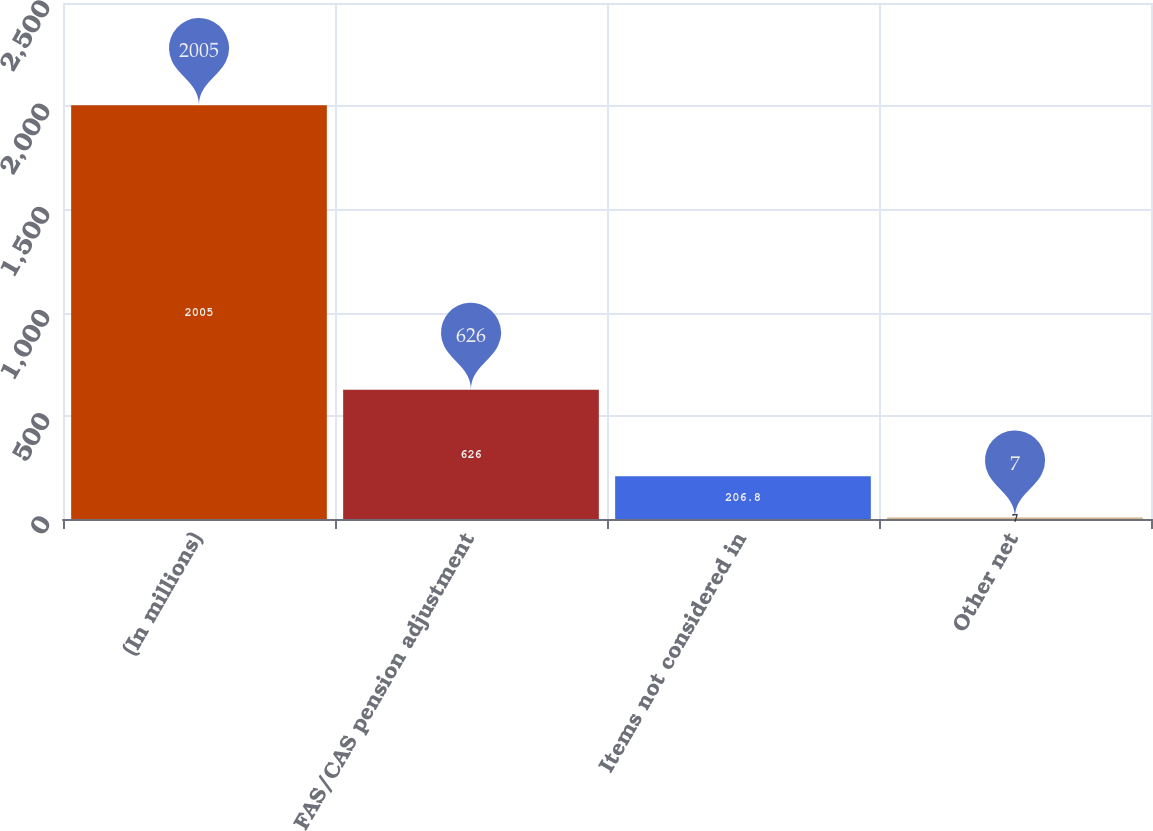<chart> <loc_0><loc_0><loc_500><loc_500><bar_chart><fcel>(In millions)<fcel>FAS/CAS pension adjustment<fcel>Items not considered in<fcel>Other net<nl><fcel>2005<fcel>626<fcel>206.8<fcel>7<nl></chart> 